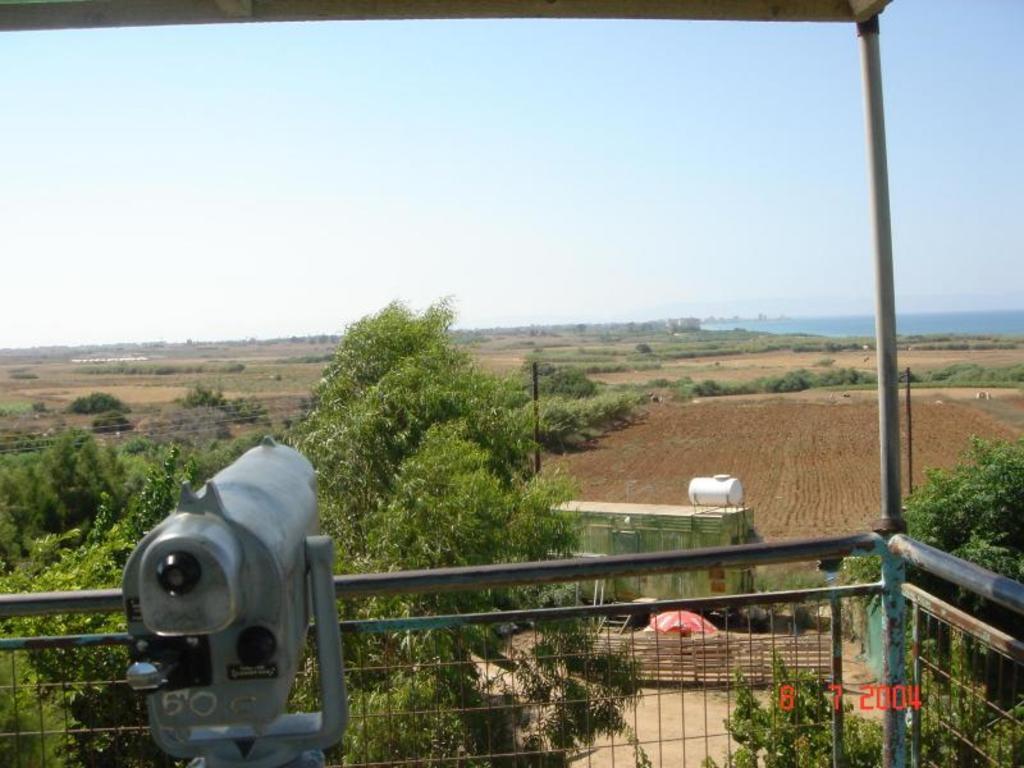Please provide a concise description of this image. In this image, we can see a metal object and the fence. We can see some grass, plants, trees. We can see the ground with some objects. We can see some wires and the sky. 